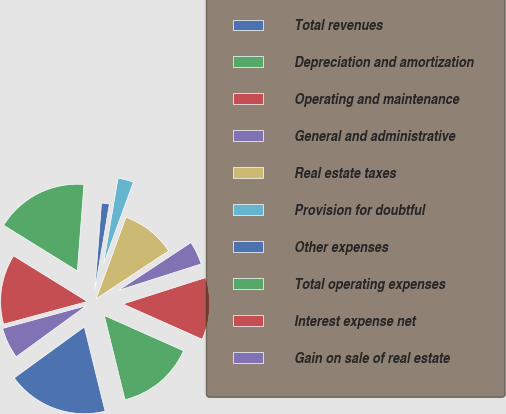Convert chart. <chart><loc_0><loc_0><loc_500><loc_500><pie_chart><fcel>Total revenues<fcel>Depreciation and amortization<fcel>Operating and maintenance<fcel>General and administrative<fcel>Real estate taxes<fcel>Provision for doubtful<fcel>Other expenses<fcel>Total operating expenses<fcel>Interest expense net<fcel>Gain on sale of real estate<nl><fcel>18.83%<fcel>14.49%<fcel>11.59%<fcel>4.36%<fcel>10.14%<fcel>2.91%<fcel>1.46%<fcel>17.38%<fcel>13.04%<fcel>5.8%<nl></chart> 